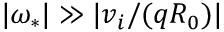Convert formula to latex. <formula><loc_0><loc_0><loc_500><loc_500>| \omega _ { * } | \gg | v _ { i } / ( q R _ { 0 } ) |</formula> 